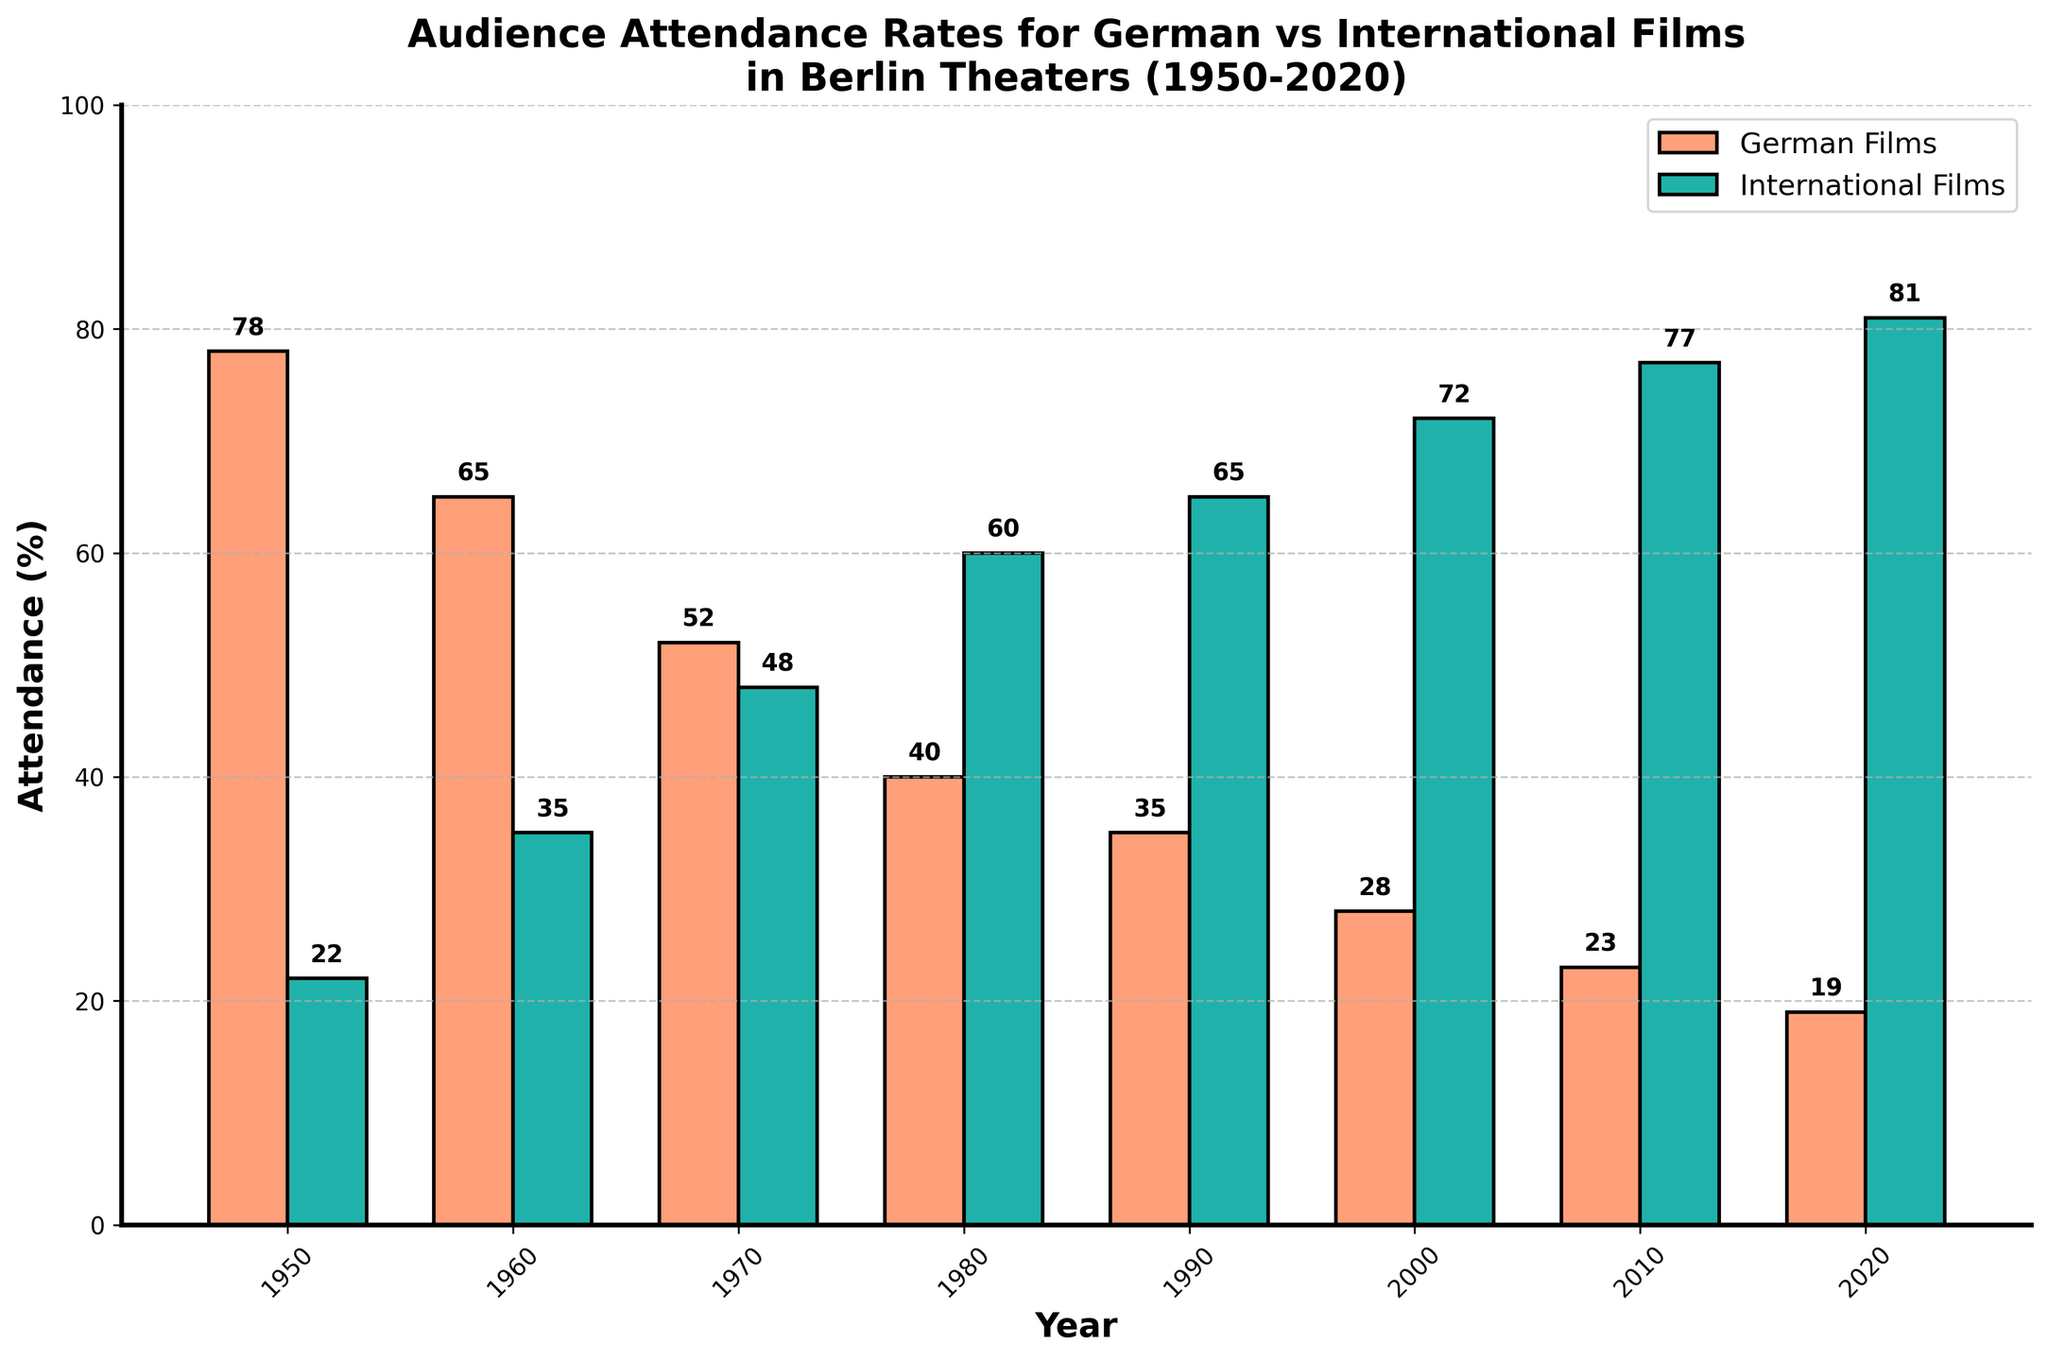Which year had the highest attendance for German films? We observe the highest bar for German Films which is in the year 1950 indicating the highest attendance.
Answer: 1950 Which year had the lowest attendance for German films? We look for the shortest bar for German Films which is in the year 2020.
Answer: 2020 In which decade did the attendance for international films first exceed 50%? Observing the bars, the blue bar surpasses 50% for the first time in the year 1980.
Answer: 1980s What was the difference in attendance percentage between German films and international films in 1960? For 1960, German Films attendance is 65% and International Films is 35%. The difference is calculated as 65% - 35%.
Answer: 30% What was the average attendance percentage for German films across all the given years? We add the German Films percentages (78 + 65 + 52 + 40 + 35 + 28 + 23 + 19) which equals 340, then divide by the number of years which is 8. The average is 340/8.
Answer: 42.5% How did the attendance for international films change from 1950 to 2020? We compare the attendance of International Films in 1950 (22%) and 2020 (81%). It increased from 22% to 81% over the given period.
Answer: Increased In which decade did the attendance for German films fall below 50%? By observing the orange bars, we see they fall below the halfway mark (50%) for the first time in the year 1970.
Answer: 1970s Which period experienced the largest decrease in German film attendance? Comparing the differences year-on-year for German Films, the largest decrease occurs between 2000 and 2010 dropping from 28% to 23%. The difference is 28% - 23%.
Answer: 2000-2010 Is there a year where the attendance for German and international films was equal? Looking at the bars, there is no year where the orange and blue bars are of equal height.
Answer: No What was the total attendance percentage for all films in 1990? For 1990, German Films attendance is 35% and International Films attendance is 65%. Adding both percentages, the total is 35% + 65%.
Answer: 100% 